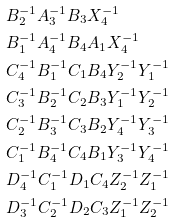Convert formula to latex. <formula><loc_0><loc_0><loc_500><loc_500>& B _ { 2 } ^ { - 1 } A _ { 3 } ^ { - 1 } B _ { 3 } X _ { 4 } ^ { - 1 } \\ & B _ { 1 } ^ { - 1 } A _ { 4 } ^ { - 1 } B _ { 4 } A _ { 1 } X _ { 4 } ^ { - 1 } \\ & C _ { 4 } ^ { - 1 } B _ { 1 } ^ { - 1 } C _ { 1 } B _ { 4 } Y _ { 2 } ^ { - 1 } Y _ { 1 } ^ { - 1 } \\ & C _ { 3 } ^ { - 1 } B _ { 2 } ^ { - 1 } C _ { 2 } B _ { 3 } Y _ { 1 } ^ { - 1 } Y _ { 2 } ^ { - 1 } \\ & C _ { 2 } ^ { - 1 } B _ { 3 } ^ { - 1 } C _ { 3 } B _ { 2 } Y _ { 4 } ^ { - 1 } Y _ { 3 } ^ { - 1 } \\ & C _ { 1 } ^ { - 1 } B _ { 4 } ^ { - 1 } C _ { 4 } B _ { 1 } Y _ { 3 } ^ { - 1 } Y _ { 4 } ^ { - 1 } \\ & D _ { 4 } ^ { - 1 } C _ { 1 } ^ { - 1 } D _ { 1 } C _ { 4 } Z _ { 2 } ^ { - 1 } Z _ { 1 } ^ { - 1 } \\ & D _ { 3 } ^ { - 1 } C _ { 2 } ^ { - 1 } D _ { 2 } C _ { 3 } Z _ { 1 } ^ { - 1 } Z _ { 2 } ^ { - 1 }</formula> 